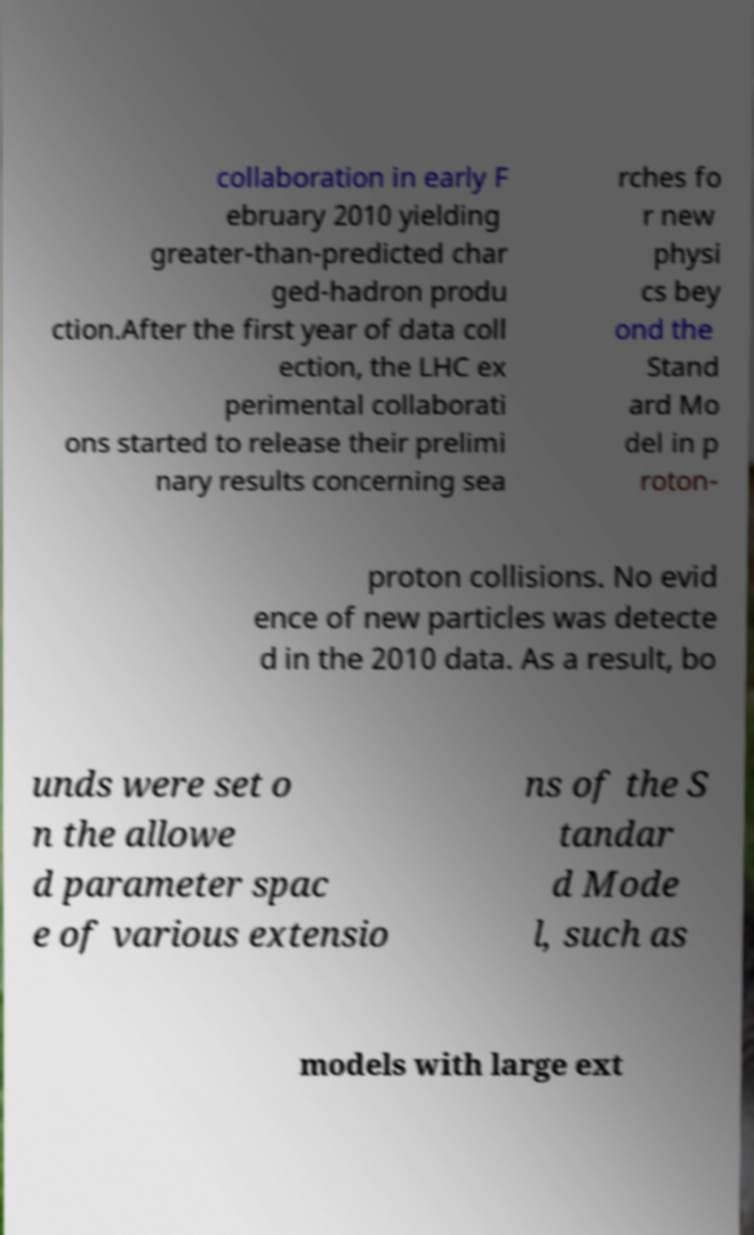What messages or text are displayed in this image? I need them in a readable, typed format. collaboration in early F ebruary 2010 yielding greater-than-predicted char ged-hadron produ ction.After the first year of data coll ection, the LHC ex perimental collaborati ons started to release their prelimi nary results concerning sea rches fo r new physi cs bey ond the Stand ard Mo del in p roton- proton collisions. No evid ence of new particles was detecte d in the 2010 data. As a result, bo unds were set o n the allowe d parameter spac e of various extensio ns of the S tandar d Mode l, such as models with large ext 